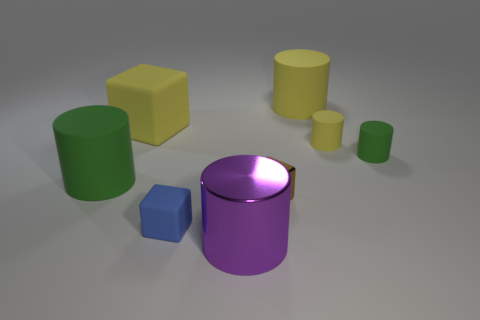Subtract all small yellow cylinders. How many cylinders are left? 4 Add 1 cyan cylinders. How many objects exist? 9 Subtract 2 cylinders. How many cylinders are left? 3 Subtract all yellow cylinders. How many cylinders are left? 3 Subtract all brown cylinders. How many yellow blocks are left? 1 Subtract all large green cylinders. Subtract all large gray balls. How many objects are left? 7 Add 7 big purple cylinders. How many big purple cylinders are left? 8 Add 8 tiny red cylinders. How many tiny red cylinders exist? 8 Subtract 0 brown cylinders. How many objects are left? 8 Subtract all cubes. How many objects are left? 5 